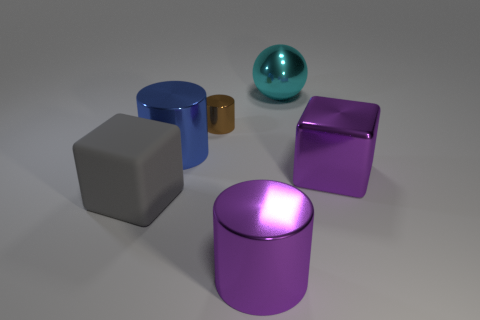Add 2 cyan metal balls. How many objects exist? 8 Subtract all large shiny cylinders. How many cylinders are left? 1 Subtract all blocks. How many objects are left? 4 Subtract 1 blocks. How many blocks are left? 1 Subtract all brown cylinders. How many cylinders are left? 2 Subtract 0 yellow cylinders. How many objects are left? 6 Subtract all yellow cylinders. Subtract all yellow spheres. How many cylinders are left? 3 Subtract all tiny metallic cylinders. Subtract all large gray shiny cylinders. How many objects are left? 5 Add 4 gray rubber objects. How many gray rubber objects are left? 5 Add 1 blue shiny spheres. How many blue shiny spheres exist? 1 